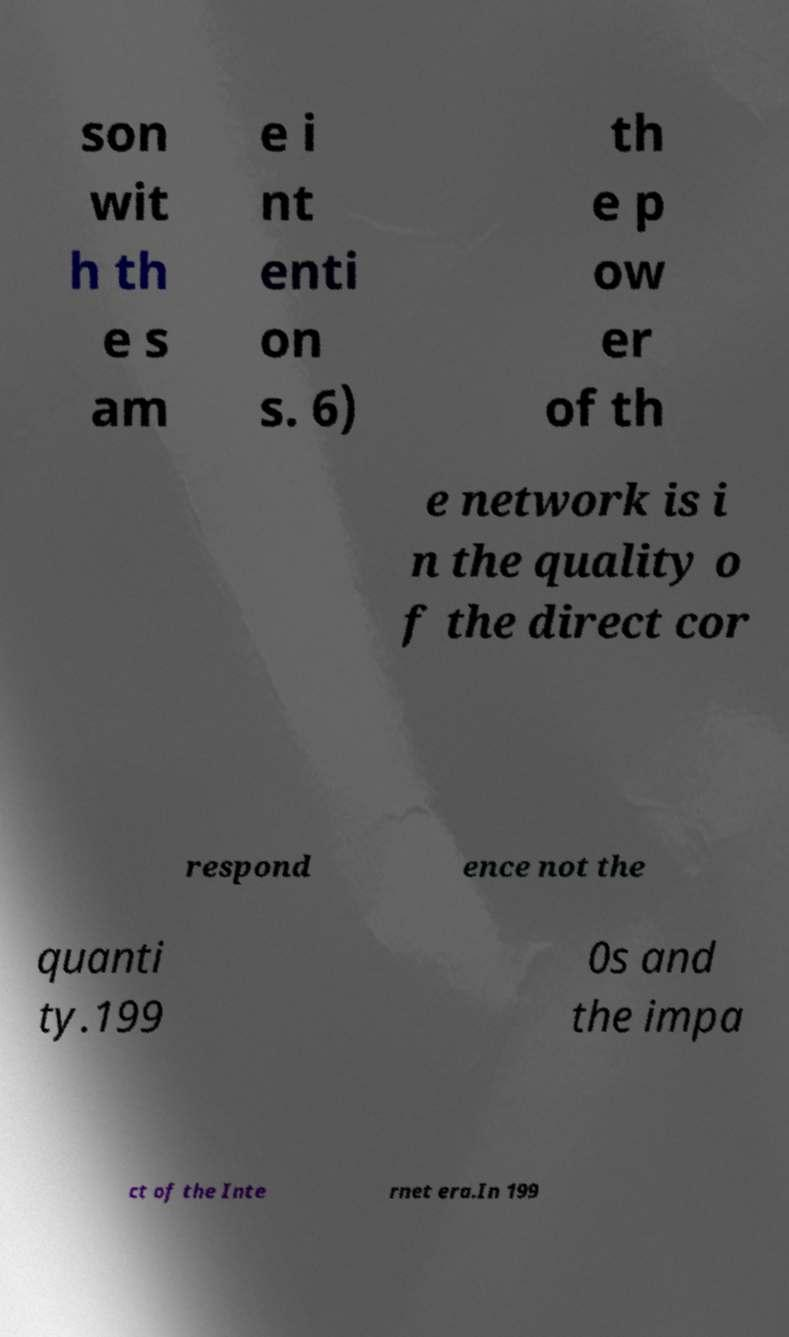I need the written content from this picture converted into text. Can you do that? son wit h th e s am e i nt enti on s. 6) th e p ow er of th e network is i n the quality o f the direct cor respond ence not the quanti ty.199 0s and the impa ct of the Inte rnet era.In 199 